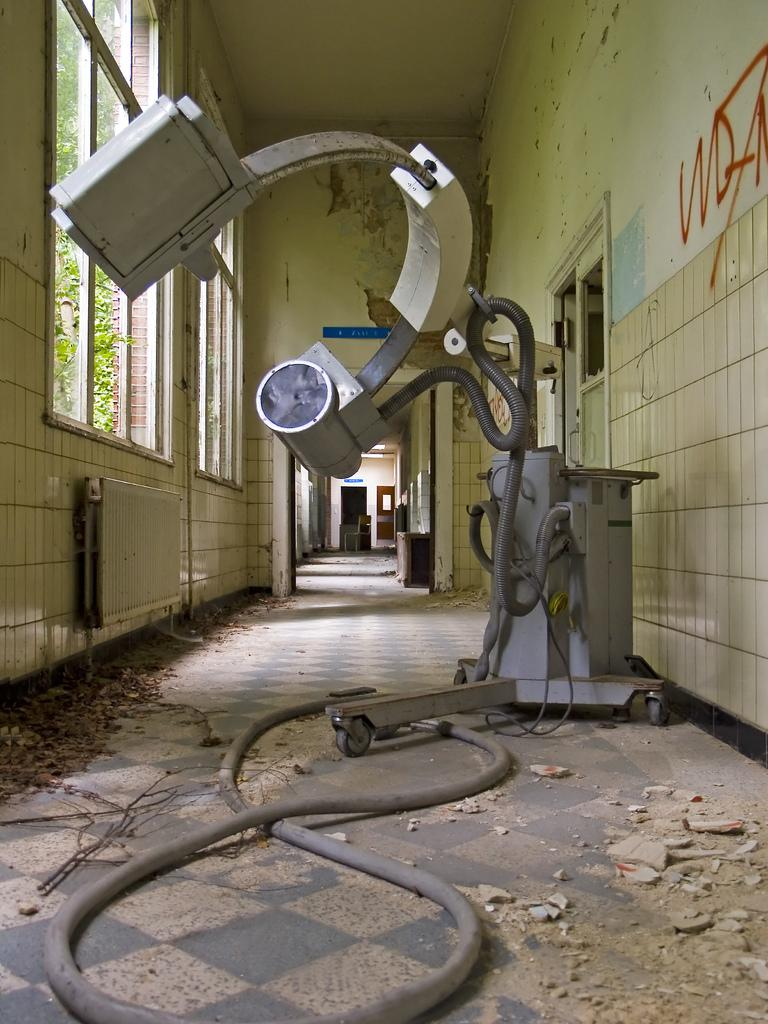What is the main subject of the image? The main subject of the image is an hospital machine. Where is the hospital machine located in the image? The hospital machine is at the center of the image. What can be seen on the right side of the image? There is graffiti on the right wall in the image. What is visible to the left of the machine in the image? There are windows to the left of the machine in the image. What is located behind the machine in the image? There is a door behind the machine in the image. How many snails can be seen crawling on the hospital machine in the image? There are no snails present on the hospital machine in the image. What type of bell is hanging near the door in the image? There is no bell visible in the image. 